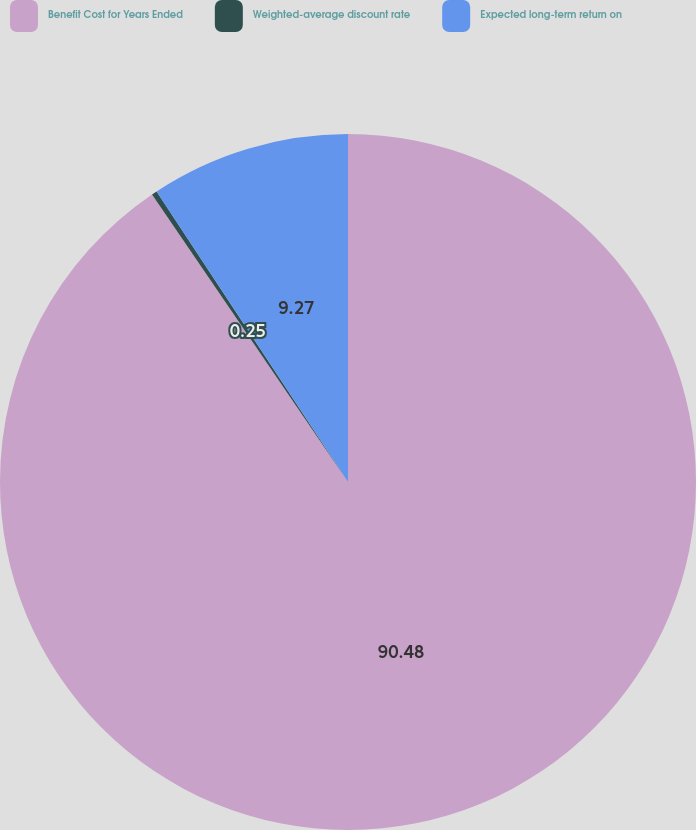Convert chart to OTSL. <chart><loc_0><loc_0><loc_500><loc_500><pie_chart><fcel>Benefit Cost for Years Ended<fcel>Weighted-average discount rate<fcel>Expected long-term return on<nl><fcel>90.48%<fcel>0.25%<fcel>9.27%<nl></chart> 